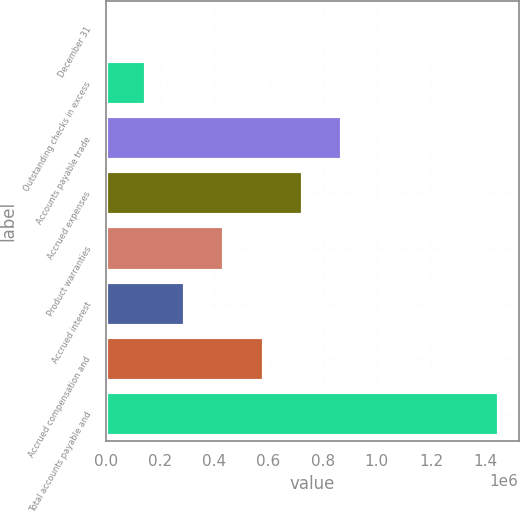Convert chart. <chart><loc_0><loc_0><loc_500><loc_500><bar_chart><fcel>December 31<fcel>Outstanding checks in excess<fcel>Accounts payable trade<fcel>Accrued expenses<fcel>Product warranties<fcel>Accrued interest<fcel>Accrued compensation and<fcel>Total accounts payable and<nl><fcel>2017<fcel>146982<fcel>871810<fcel>726844<fcel>436914<fcel>291948<fcel>581879<fcel>1.45167e+06<nl></chart> 